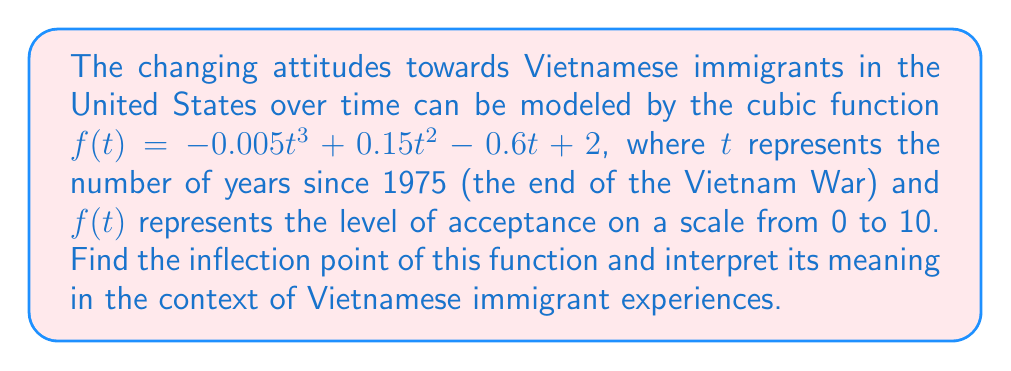What is the answer to this math problem? To find the inflection point of a cubic function, we need to follow these steps:

1) The inflection point occurs where the second derivative of the function equals zero.

2) First, let's find the first derivative:
   $f'(t) = -0.015t^2 + 0.3t - 0.6$

3) Now, let's find the second derivative:
   $f''(t) = -0.03t + 0.3$

4) Set the second derivative equal to zero and solve for t:
   $-0.03t + 0.3 = 0$
   $-0.03t = -0.3$
   $t = 10$

5) To verify this is indeed an inflection point, we can check if $f''(t)$ changes sign around $t = 10$:
   $f''(9) = 0.03 > 0$
   $f''(11) = -0.03 < 0$
   
   Since the sign changes, $t = 10$ is confirmed as the inflection point.

6) To find the y-coordinate of the inflection point, we substitute $t = 10$ into the original function:
   $f(10) = -0.005(10^3) + 0.15(10^2) - 0.6(10) + 2$
   $= -5 + 15 - 6 + 2 = 6$

Therefore, the inflection point is (10, 6).

Interpretation: The inflection point occurs 10 years after 1975, which is 1985. This suggests that around 1985, there was a shift in the rate of change of attitudes towards Vietnamese immigrants. Before this point, the rate of acceptance was increasing at an increasing rate. After this point, the rate of acceptance continued to increase but at a decreasing rate. The level of acceptance at this turning point was 6 out of 10, indicating a moderate level of acceptance in the mid-1980s.
Answer: The inflection point is (10, 6), occurring in 1985 with an acceptance level of 6 out of 10. 